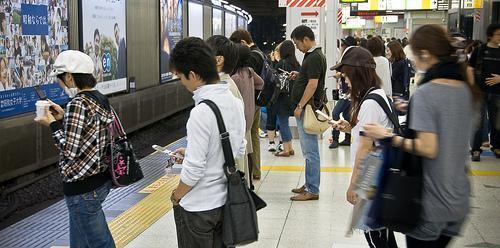How many people are there?
Give a very brief answer. 6. How many handbags are there?
Give a very brief answer. 2. How many cows a man is holding?
Give a very brief answer. 0. 